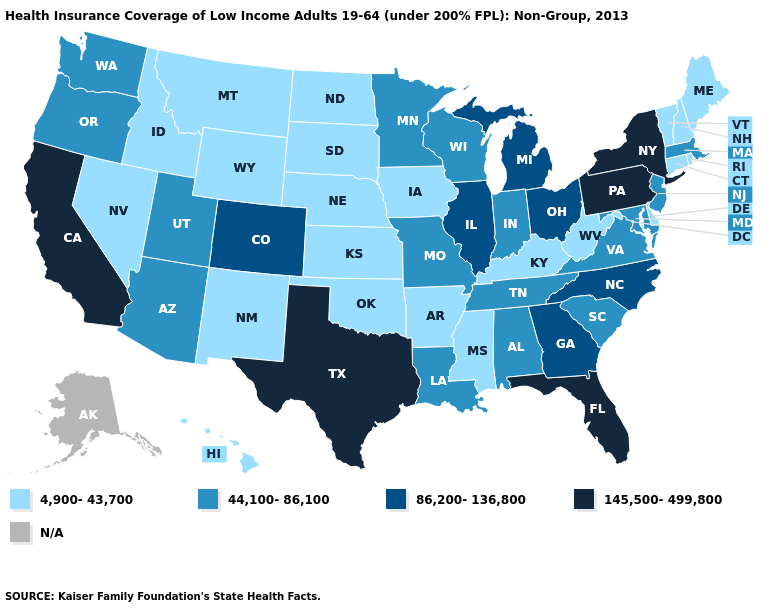What is the value of Minnesota?
Write a very short answer. 44,100-86,100. Does Missouri have the highest value in the MidWest?
Keep it brief. No. Name the states that have a value in the range 86,200-136,800?
Concise answer only. Colorado, Georgia, Illinois, Michigan, North Carolina, Ohio. Is the legend a continuous bar?
Keep it brief. No. What is the lowest value in the South?
Answer briefly. 4,900-43,700. How many symbols are there in the legend?
Be succinct. 5. Name the states that have a value in the range 86,200-136,800?
Concise answer only. Colorado, Georgia, Illinois, Michigan, North Carolina, Ohio. Name the states that have a value in the range 4,900-43,700?
Concise answer only. Arkansas, Connecticut, Delaware, Hawaii, Idaho, Iowa, Kansas, Kentucky, Maine, Mississippi, Montana, Nebraska, Nevada, New Hampshire, New Mexico, North Dakota, Oklahoma, Rhode Island, South Dakota, Vermont, West Virginia, Wyoming. What is the value of Maryland?
Be succinct. 44,100-86,100. What is the value of Wyoming?
Write a very short answer. 4,900-43,700. Name the states that have a value in the range 145,500-499,800?
Quick response, please. California, Florida, New York, Pennsylvania, Texas. Which states have the highest value in the USA?
Short answer required. California, Florida, New York, Pennsylvania, Texas. Name the states that have a value in the range 4,900-43,700?
Be succinct. Arkansas, Connecticut, Delaware, Hawaii, Idaho, Iowa, Kansas, Kentucky, Maine, Mississippi, Montana, Nebraska, Nevada, New Hampshire, New Mexico, North Dakota, Oklahoma, Rhode Island, South Dakota, Vermont, West Virginia, Wyoming. Which states hav the highest value in the West?
Answer briefly. California. 